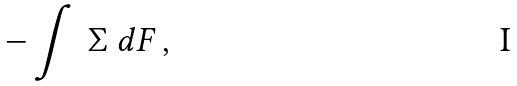<formula> <loc_0><loc_0><loc_500><loc_500>- \int \ \Sigma \ d F \, ,</formula> 